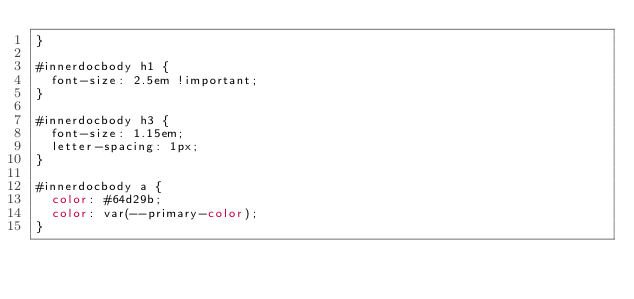<code> <loc_0><loc_0><loc_500><loc_500><_CSS_>}

#innerdocbody h1 {
  font-size: 2.5em !important;
}

#innerdocbody h3 {
  font-size: 1.15em;
  letter-spacing: 1px;
}

#innerdocbody a {
  color: #64d29b;
  color: var(--primary-color);
}</code> 